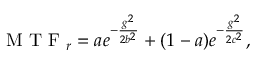<formula> <loc_0><loc_0><loc_500><loc_500>M T F _ { r } = a e ^ { - \frac { g ^ { 2 } } { 2 b ^ { 2 } } } + ( 1 - a ) e ^ { - \frac { g ^ { 2 } } { 2 c ^ { 2 } } } ,</formula> 